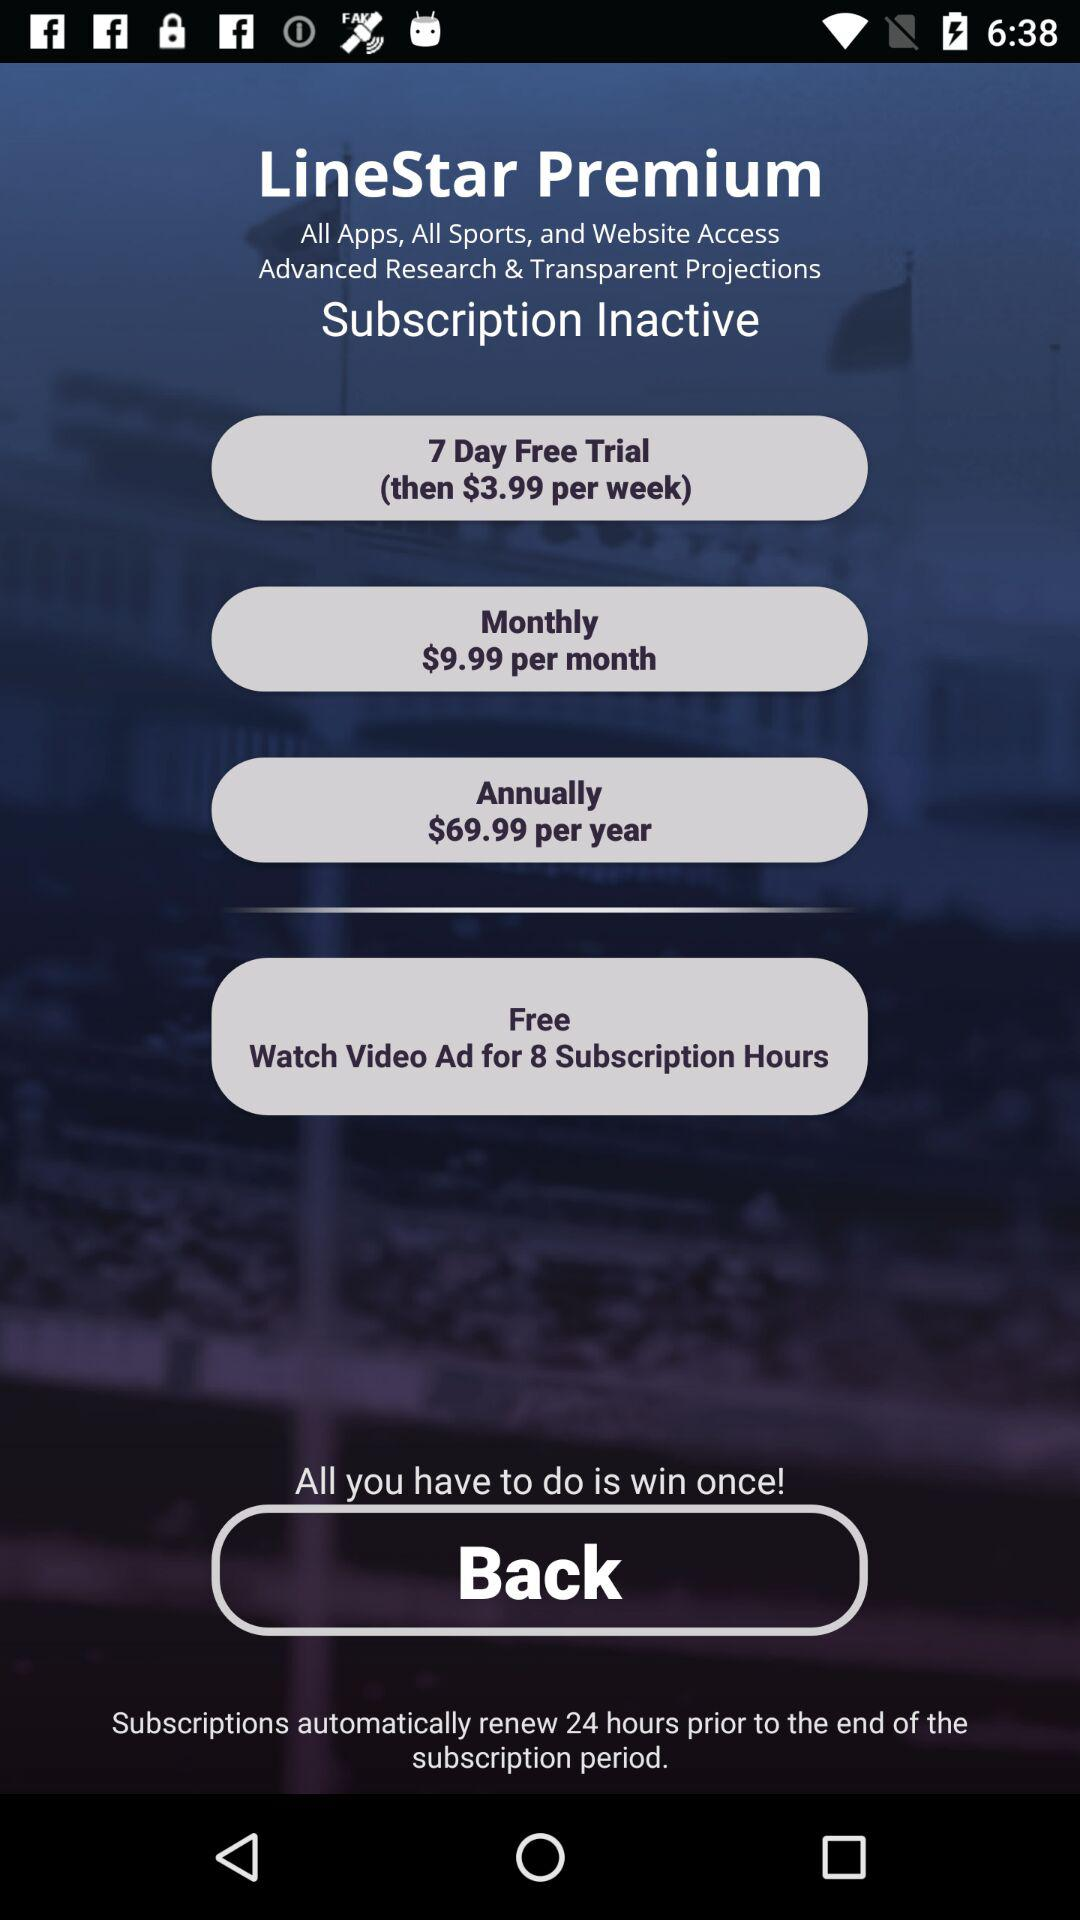What is the application name? The application name is "LineStar". 